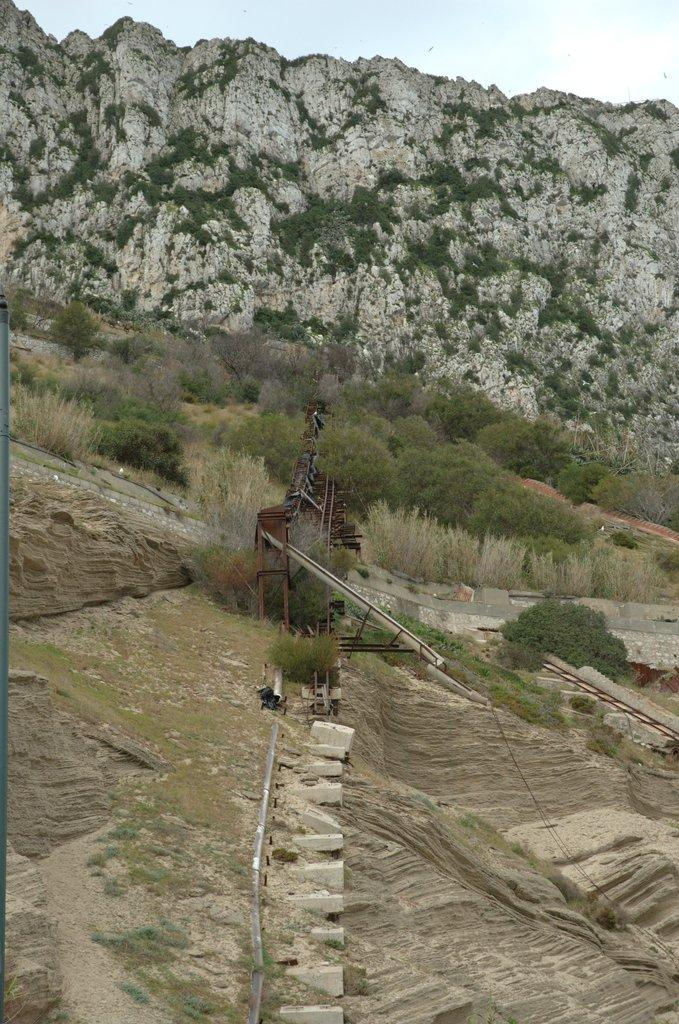What type of vegetation is present on the ground in the image? There are trees and plants on the ground in the image. What geographical feature can be seen in the image? There is a hill in the image. What part of the natural environment is visible in the background of the image? The sky is visible in the background of the image. Where is the hydrant located in the image? There is no hydrant present in the image. What type of pancake can be seen on the hill in the image? There is no pancake present in the image; the hill features trees and plants. 